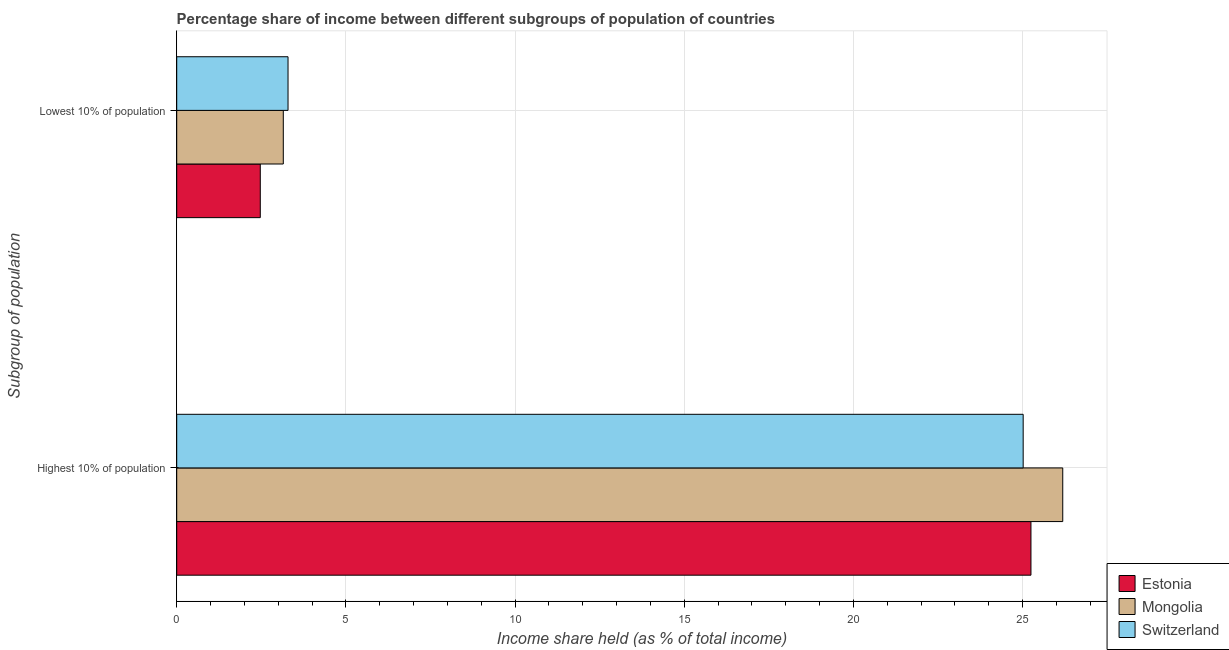How many different coloured bars are there?
Provide a succinct answer. 3. Are the number of bars per tick equal to the number of legend labels?
Give a very brief answer. Yes. Are the number of bars on each tick of the Y-axis equal?
Provide a short and direct response. Yes. How many bars are there on the 1st tick from the bottom?
Ensure brevity in your answer.  3. What is the label of the 2nd group of bars from the top?
Offer a terse response. Highest 10% of population. What is the income share held by lowest 10% of the population in Switzerland?
Keep it short and to the point. 3.29. Across all countries, what is the maximum income share held by lowest 10% of the population?
Provide a succinct answer. 3.29. Across all countries, what is the minimum income share held by highest 10% of the population?
Provide a succinct answer. 25.02. In which country was the income share held by highest 10% of the population maximum?
Make the answer very short. Mongolia. In which country was the income share held by lowest 10% of the population minimum?
Ensure brevity in your answer.  Estonia. What is the total income share held by highest 10% of the population in the graph?
Ensure brevity in your answer.  76.46. What is the difference between the income share held by lowest 10% of the population in Switzerland and that in Estonia?
Give a very brief answer. 0.82. What is the difference between the income share held by lowest 10% of the population in Estonia and the income share held by highest 10% of the population in Switzerland?
Offer a terse response. -22.55. What is the average income share held by lowest 10% of the population per country?
Offer a very short reply. 2.97. What is the difference between the income share held by highest 10% of the population and income share held by lowest 10% of the population in Mongolia?
Give a very brief answer. 23.04. What is the ratio of the income share held by lowest 10% of the population in Switzerland to that in Estonia?
Your response must be concise. 1.33. Is the income share held by highest 10% of the population in Switzerland less than that in Mongolia?
Make the answer very short. Yes. What does the 3rd bar from the top in Highest 10% of population represents?
Keep it short and to the point. Estonia. What does the 3rd bar from the bottom in Highest 10% of population represents?
Make the answer very short. Switzerland. How many bars are there?
Offer a terse response. 6. Are all the bars in the graph horizontal?
Offer a terse response. Yes. How many legend labels are there?
Your response must be concise. 3. How are the legend labels stacked?
Provide a short and direct response. Vertical. What is the title of the graph?
Provide a short and direct response. Percentage share of income between different subgroups of population of countries. What is the label or title of the X-axis?
Keep it short and to the point. Income share held (as % of total income). What is the label or title of the Y-axis?
Provide a short and direct response. Subgroup of population. What is the Income share held (as % of total income) in Estonia in Highest 10% of population?
Your answer should be very brief. 25.25. What is the Income share held (as % of total income) of Mongolia in Highest 10% of population?
Give a very brief answer. 26.19. What is the Income share held (as % of total income) of Switzerland in Highest 10% of population?
Your answer should be very brief. 25.02. What is the Income share held (as % of total income) of Estonia in Lowest 10% of population?
Offer a very short reply. 2.47. What is the Income share held (as % of total income) in Mongolia in Lowest 10% of population?
Offer a terse response. 3.15. What is the Income share held (as % of total income) in Switzerland in Lowest 10% of population?
Give a very brief answer. 3.29. Across all Subgroup of population, what is the maximum Income share held (as % of total income) of Estonia?
Your answer should be compact. 25.25. Across all Subgroup of population, what is the maximum Income share held (as % of total income) in Mongolia?
Offer a very short reply. 26.19. Across all Subgroup of population, what is the maximum Income share held (as % of total income) of Switzerland?
Ensure brevity in your answer.  25.02. Across all Subgroup of population, what is the minimum Income share held (as % of total income) in Estonia?
Give a very brief answer. 2.47. Across all Subgroup of population, what is the minimum Income share held (as % of total income) in Mongolia?
Keep it short and to the point. 3.15. Across all Subgroup of population, what is the minimum Income share held (as % of total income) of Switzerland?
Your answer should be very brief. 3.29. What is the total Income share held (as % of total income) in Estonia in the graph?
Offer a terse response. 27.72. What is the total Income share held (as % of total income) in Mongolia in the graph?
Give a very brief answer. 29.34. What is the total Income share held (as % of total income) of Switzerland in the graph?
Give a very brief answer. 28.31. What is the difference between the Income share held (as % of total income) in Estonia in Highest 10% of population and that in Lowest 10% of population?
Keep it short and to the point. 22.78. What is the difference between the Income share held (as % of total income) of Mongolia in Highest 10% of population and that in Lowest 10% of population?
Give a very brief answer. 23.04. What is the difference between the Income share held (as % of total income) in Switzerland in Highest 10% of population and that in Lowest 10% of population?
Make the answer very short. 21.73. What is the difference between the Income share held (as % of total income) in Estonia in Highest 10% of population and the Income share held (as % of total income) in Mongolia in Lowest 10% of population?
Ensure brevity in your answer.  22.1. What is the difference between the Income share held (as % of total income) of Estonia in Highest 10% of population and the Income share held (as % of total income) of Switzerland in Lowest 10% of population?
Ensure brevity in your answer.  21.96. What is the difference between the Income share held (as % of total income) in Mongolia in Highest 10% of population and the Income share held (as % of total income) in Switzerland in Lowest 10% of population?
Provide a short and direct response. 22.9. What is the average Income share held (as % of total income) in Estonia per Subgroup of population?
Your response must be concise. 13.86. What is the average Income share held (as % of total income) of Mongolia per Subgroup of population?
Offer a terse response. 14.67. What is the average Income share held (as % of total income) in Switzerland per Subgroup of population?
Provide a succinct answer. 14.15. What is the difference between the Income share held (as % of total income) in Estonia and Income share held (as % of total income) in Mongolia in Highest 10% of population?
Ensure brevity in your answer.  -0.94. What is the difference between the Income share held (as % of total income) of Estonia and Income share held (as % of total income) of Switzerland in Highest 10% of population?
Offer a terse response. 0.23. What is the difference between the Income share held (as % of total income) in Mongolia and Income share held (as % of total income) in Switzerland in Highest 10% of population?
Provide a short and direct response. 1.17. What is the difference between the Income share held (as % of total income) of Estonia and Income share held (as % of total income) of Mongolia in Lowest 10% of population?
Your answer should be compact. -0.68. What is the difference between the Income share held (as % of total income) of Estonia and Income share held (as % of total income) of Switzerland in Lowest 10% of population?
Your answer should be compact. -0.82. What is the difference between the Income share held (as % of total income) in Mongolia and Income share held (as % of total income) in Switzerland in Lowest 10% of population?
Your answer should be very brief. -0.14. What is the ratio of the Income share held (as % of total income) in Estonia in Highest 10% of population to that in Lowest 10% of population?
Give a very brief answer. 10.22. What is the ratio of the Income share held (as % of total income) of Mongolia in Highest 10% of population to that in Lowest 10% of population?
Provide a short and direct response. 8.31. What is the ratio of the Income share held (as % of total income) of Switzerland in Highest 10% of population to that in Lowest 10% of population?
Give a very brief answer. 7.6. What is the difference between the highest and the second highest Income share held (as % of total income) of Estonia?
Give a very brief answer. 22.78. What is the difference between the highest and the second highest Income share held (as % of total income) in Mongolia?
Give a very brief answer. 23.04. What is the difference between the highest and the second highest Income share held (as % of total income) in Switzerland?
Give a very brief answer. 21.73. What is the difference between the highest and the lowest Income share held (as % of total income) in Estonia?
Offer a very short reply. 22.78. What is the difference between the highest and the lowest Income share held (as % of total income) in Mongolia?
Keep it short and to the point. 23.04. What is the difference between the highest and the lowest Income share held (as % of total income) of Switzerland?
Your answer should be compact. 21.73. 